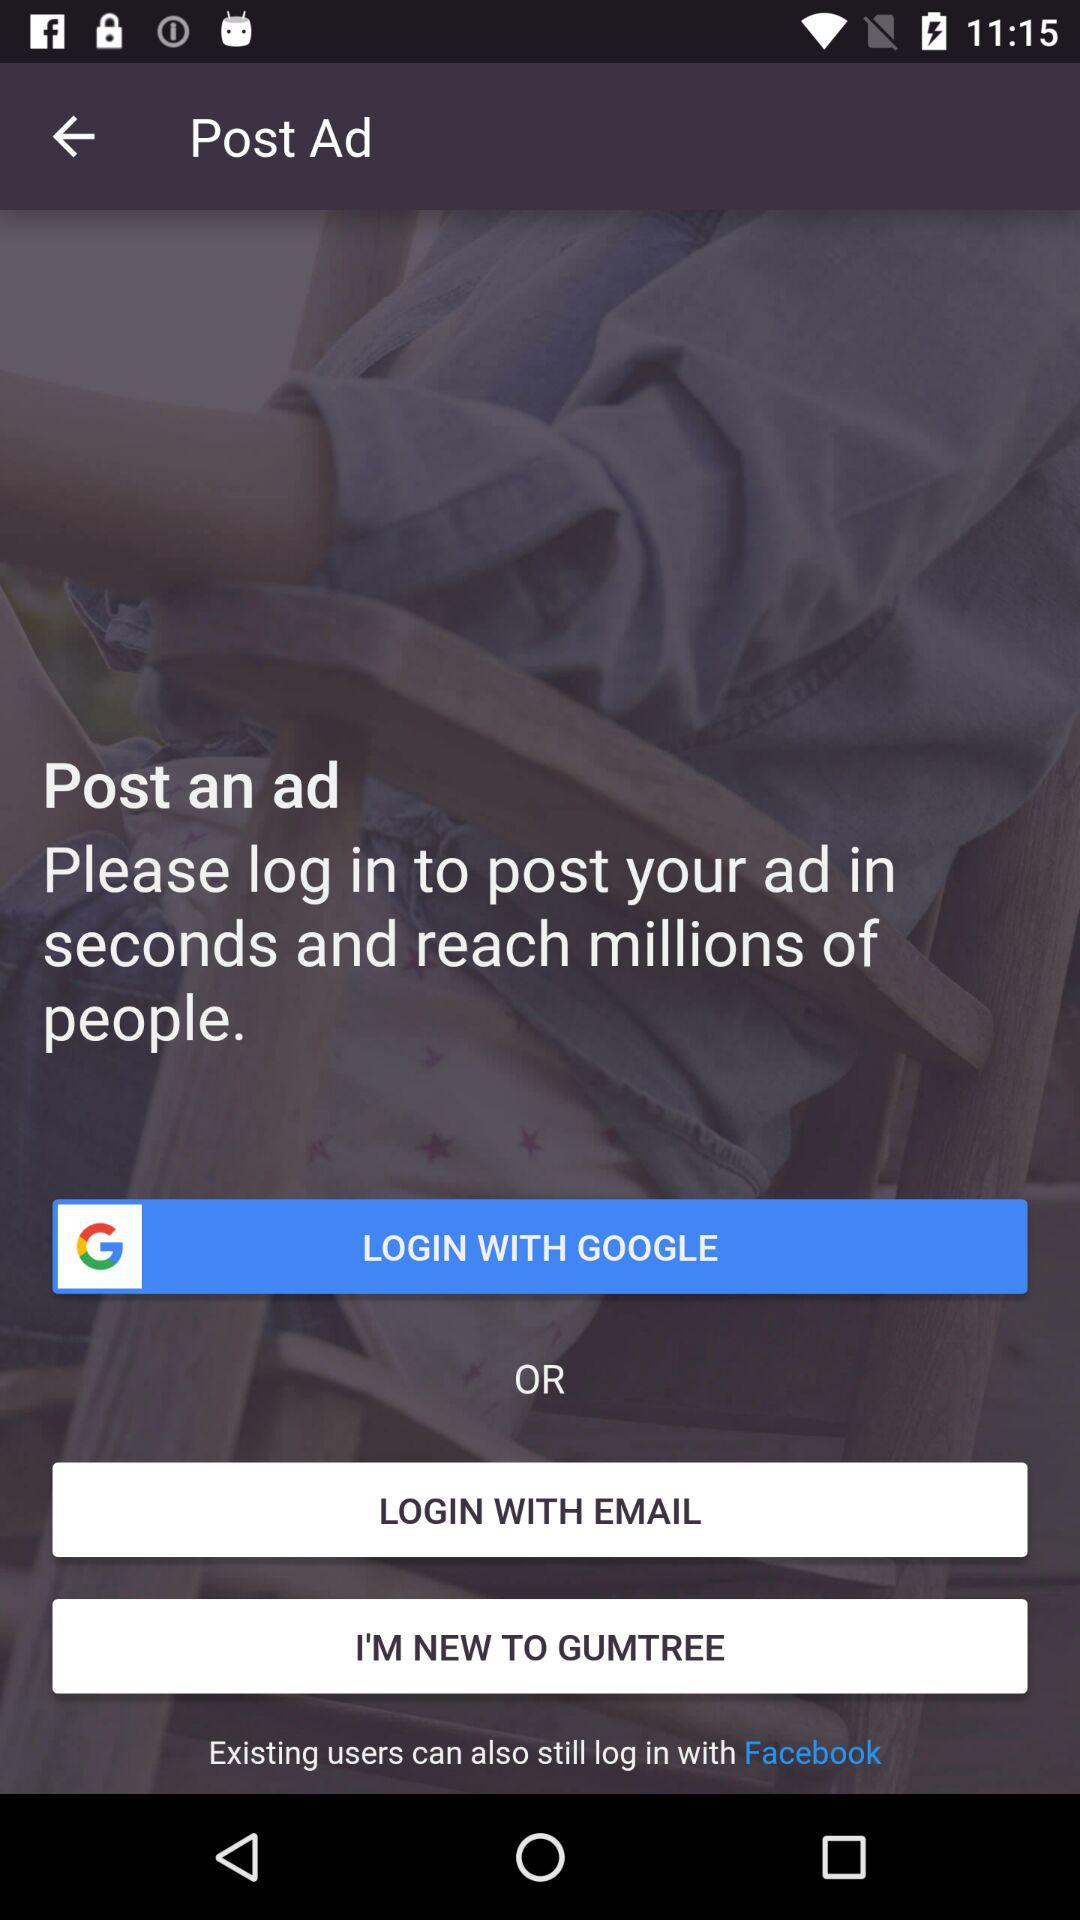How many social media login options are there?
Answer the question using a single word or phrase. 2 